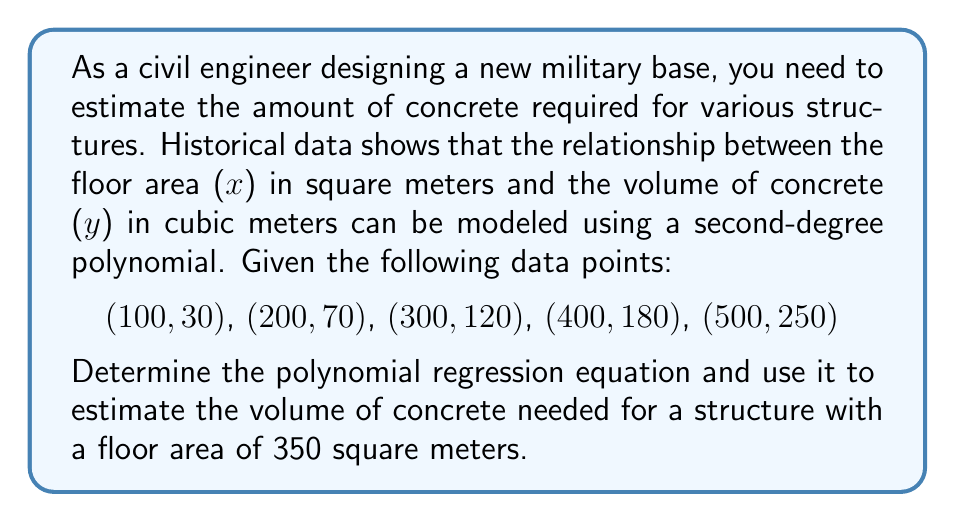Help me with this question. To solve this problem, we'll follow these steps:

1. Set up the polynomial regression equation:
   $$y = ax^2 + bx + c$$

2. Use the given data points to create a system of equations:
   $$30 = 100^2a + 100b + c$$
   $$70 = 200^2a + 200b + c$$
   $$120 = 300^2a + 300b + c$$
   $$180 = 400^2a + 400b + c$$
   $$250 = 500^2a + 500b + c$$

3. Solve the system of equations using a matrix method or software. This gives us:
   $$a = 0.00078$$
   $$b = 0.22$$
   $$c = 8$$

4. Substitute these values into the polynomial regression equation:
   $$y = 0.00078x^2 + 0.22x + 8$$

5. To estimate the volume of concrete for a floor area of 350 square meters, substitute x = 350 into the equation:
   $$y = 0.00078(350)^2 + 0.22(350) + 8$$
   $$y = 0.00078(122500) + 77 + 8$$
   $$y = 95.55 + 77 + 8$$
   $$y = 180.55$$

6. Round the result to the nearest whole number, as it's impractical to measure concrete volume to two decimal places in construction.
Answer: $y = 0.00078x^2 + 0.22x + 8$; 181 cubic meters 